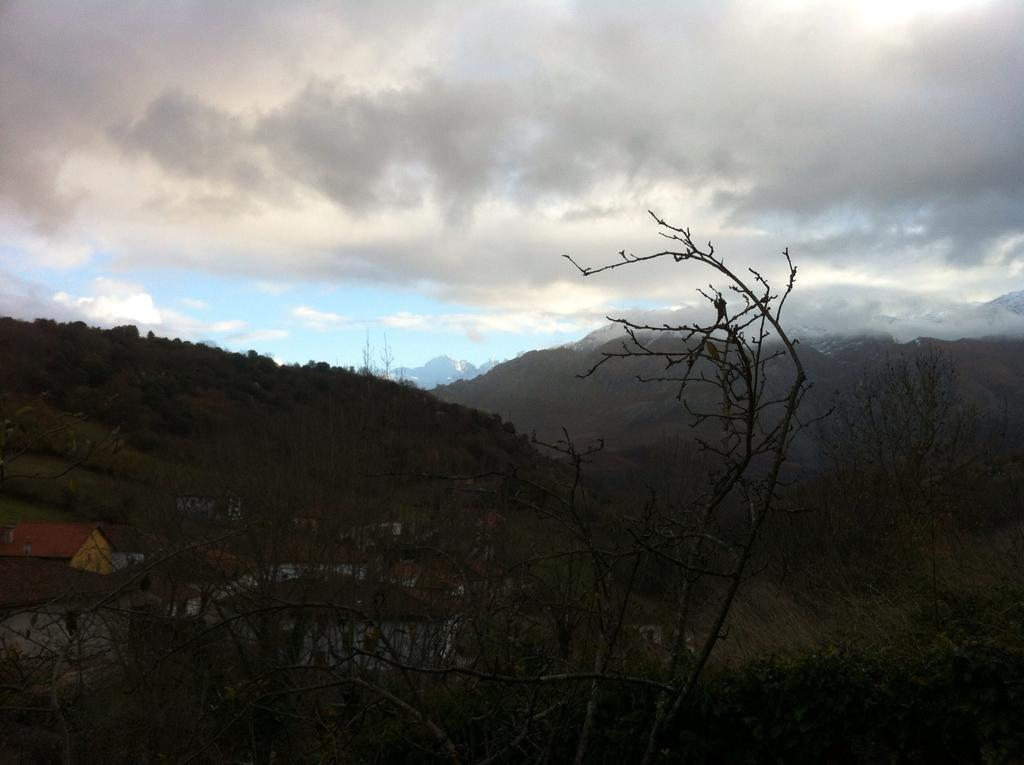What type of vegetation can be seen in the image? There are trees in the image. What type of temporary shelter is present in the image? There are tents in the image. What geographical feature can be seen in the background of the image? There are mountains in the image. What is the condition of the trees in the image? There are dry trees in the image. What is visible in the sky in the image? The sky is visible in the image, and it has blue, white, and black colors. What effect does the toe have on the house in the image? There is no toe or house present in the image, so this question cannot be answered. 